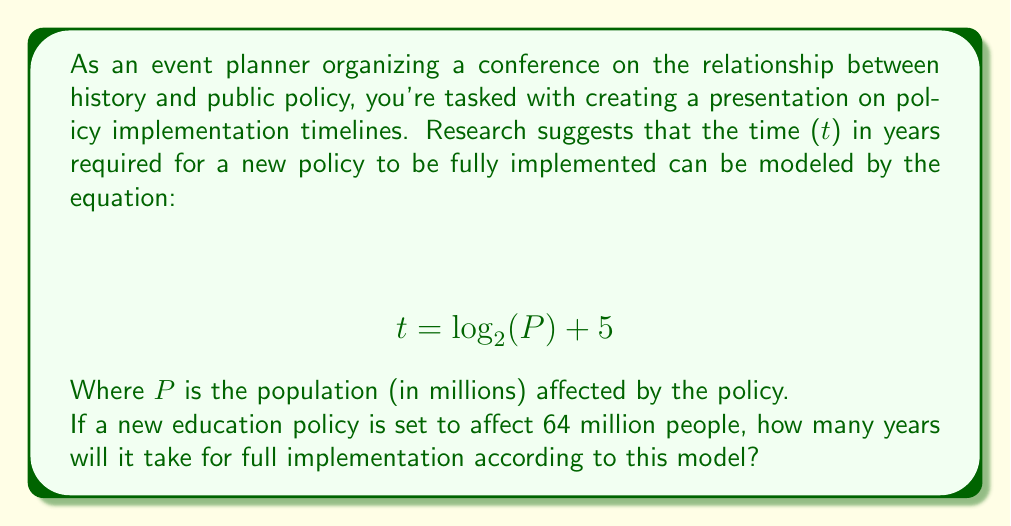Help me with this question. To solve this problem, we need to use the given logarithmic equation and substitute the known value for P.

1. Given equation: $$ t = \log_2(P) + 5 $$

2. We know that P = 64 million people. Substituting this into the equation:

   $$ t = \log_2(64) + 5 $$

3. Now, we need to evaluate $\log_2(64)$. We can do this by asking: "2 to what power equals 64?"

4. We know that $2^6 = 64$, so:

   $$ \log_2(64) = 6 $$

5. Substituting this back into our equation:

   $$ t = 6 + 5 $$

6. Simplifying:

   $$ t = 11 $$

Therefore, according to this model, it will take 11 years for the education policy to be fully implemented.
Answer: 11 years 